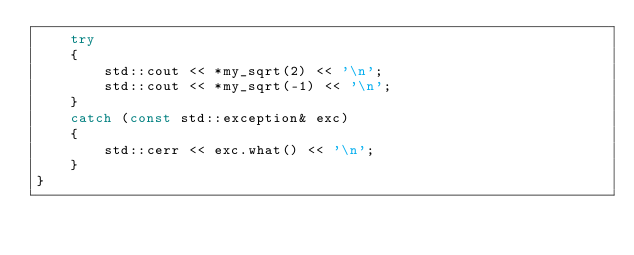<code> <loc_0><loc_0><loc_500><loc_500><_C++_>    try
    {
        std::cout << *my_sqrt(2) << '\n';
        std::cout << *my_sqrt(-1) << '\n';
    }
    catch (const std::exception& exc)
    {
        std::cerr << exc.what() << '\n';
    }
}
</code> 